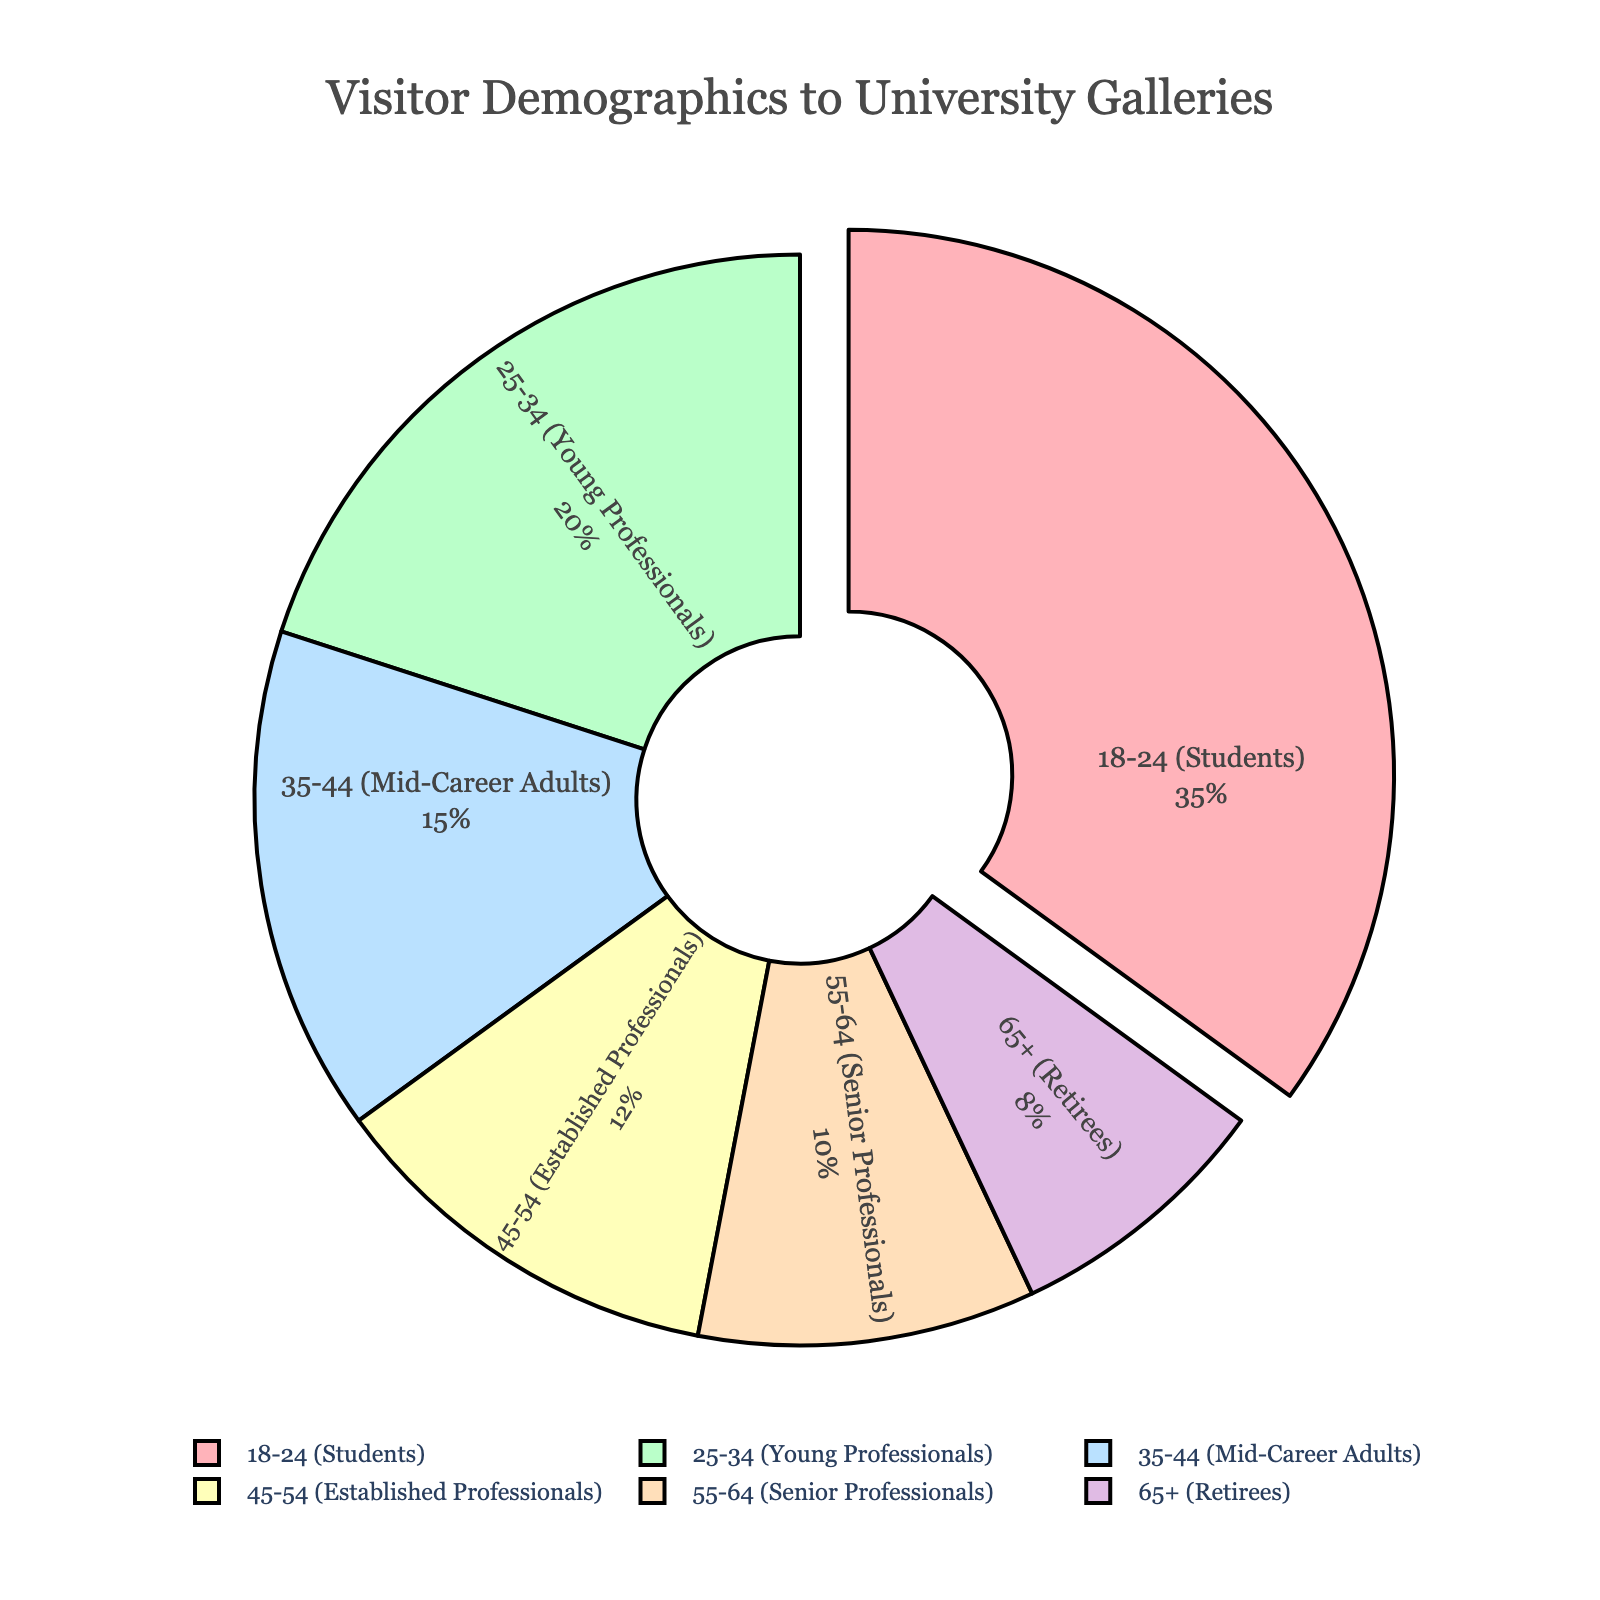What is the largest age group by percentage? The chart shows that the 18-24 (Students) age group has the highest percentage.
Answer: 18-24 (Students) Which two age groups combined make up more than half of the visitors? Adding the percentages of the 18-24 (Students) and 25-34 (Young Professionals) groups: 35% + 20% = 55%, which is more than half.
Answer: 18-24 (Students) and 25-34 (Young Professionals) How does the 65+ (Retirees) group compare to the 25-34 (Young Professionals) group? The 65+ (Retirees) group has 8%, while the 25-34 (Young Professionals) group has 20%, making the latter more than twice as large.
Answer: 25-34 (Young Professionals) has more visitors What is the combined percentage of visitors aged 55 and above? Adding the percentages of the 55-64 (Senior Professionals) and 65+ (Retirees) groups: 10% + 8% = 18%.
Answer: 18% Which group has the smallest percentage of visitors? The chart shows that the 65+ (Retirees) group has the smallest percentage at 8%.
Answer: 65+ (Retirees) By how many percentage points does the 18-24 (Students) group exceed the 45-54 (Established Professionals) group? The 18-24 (Students) group is at 35%, and the 45-54 (Established Professionals) group is at 12%. The difference is 35% - 12% = 23%.
Answer: 23 percentage points What percentage of the visitors are under 35 years old? Adding the percentages of the 18-24 (Students) and 25-34 (Young Professionals) groups: 35% + 20% = 55%.
Answer: 55% Which color represents the 35-44 (Mid-Career Adults) group? The 35-44 (Mid-Career Adults) group is represented by the light blue segment in the pie chart.
Answer: Light blue Is the total percentage of visitors aged 35-54 more than those aged 18-24? Adding the percentages for 35-44 (Mid-Career Adults) and 45-54 (Established Professionals): 15% + 12% = 27%, which is less than 35%.
Answer: No, it is less What is the average percentage of the 5 largest groups? Total of the 5 largest groups: 35% (18-24) + 20% (25-34) + 15% (35-44) + 12% (45-54) + 10% (55-64) = 92%. Average is 92% / 5 = 18.4%.
Answer: 18.4% 